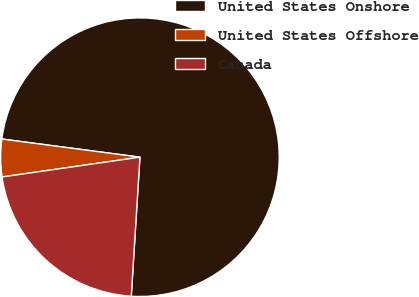Convert chart. <chart><loc_0><loc_0><loc_500><loc_500><pie_chart><fcel>United States Onshore<fcel>United States Offshore<fcel>Canada<nl><fcel>73.91%<fcel>4.35%<fcel>21.74%<nl></chart> 